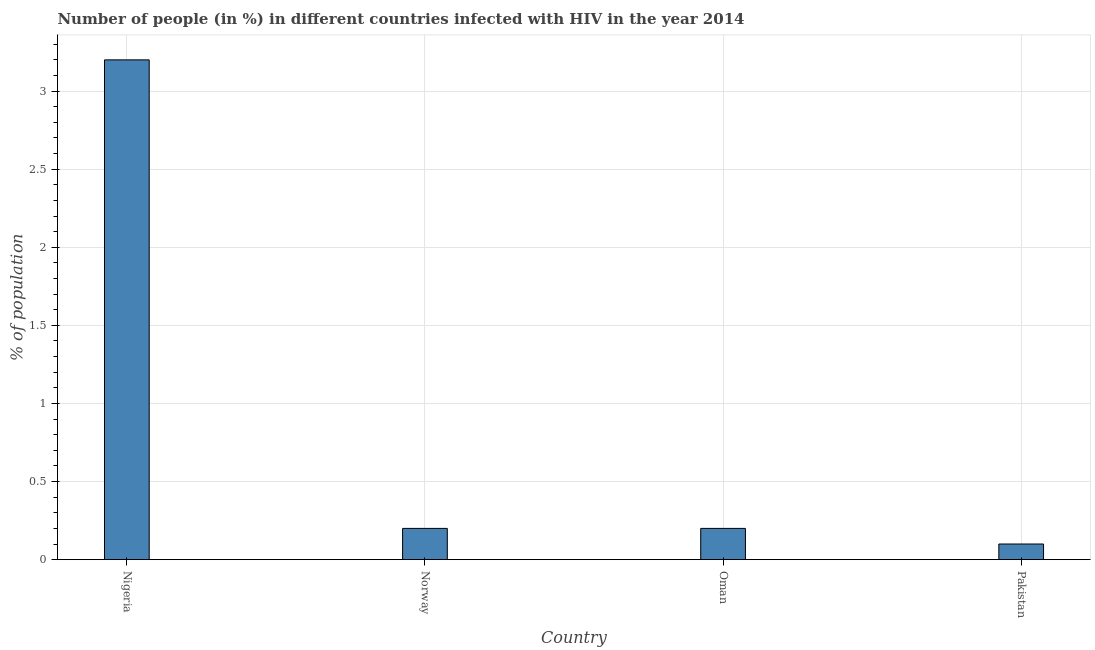What is the title of the graph?
Offer a very short reply. Number of people (in %) in different countries infected with HIV in the year 2014. What is the label or title of the Y-axis?
Offer a very short reply. % of population. What is the number of people infected with hiv in Pakistan?
Provide a succinct answer. 0.1. In which country was the number of people infected with hiv maximum?
Ensure brevity in your answer.  Nigeria. What is the sum of the number of people infected with hiv?
Offer a terse response. 3.7. What is the average number of people infected with hiv per country?
Give a very brief answer. 0.93. What is the median number of people infected with hiv?
Give a very brief answer. 0.2. What is the difference between the highest and the lowest number of people infected with hiv?
Make the answer very short. 3.1. In how many countries, is the number of people infected with hiv greater than the average number of people infected with hiv taken over all countries?
Offer a very short reply. 1. What is the difference between two consecutive major ticks on the Y-axis?
Offer a very short reply. 0.5. What is the % of population in Norway?
Provide a short and direct response. 0.2. What is the % of population of Pakistan?
Your response must be concise. 0.1. What is the difference between the % of population in Nigeria and Oman?
Your answer should be compact. 3. What is the ratio of the % of population in Nigeria to that in Oman?
Your response must be concise. 16. What is the ratio of the % of population in Norway to that in Oman?
Keep it short and to the point. 1. What is the ratio of the % of population in Norway to that in Pakistan?
Your answer should be very brief. 2. What is the ratio of the % of population in Oman to that in Pakistan?
Offer a terse response. 2. 